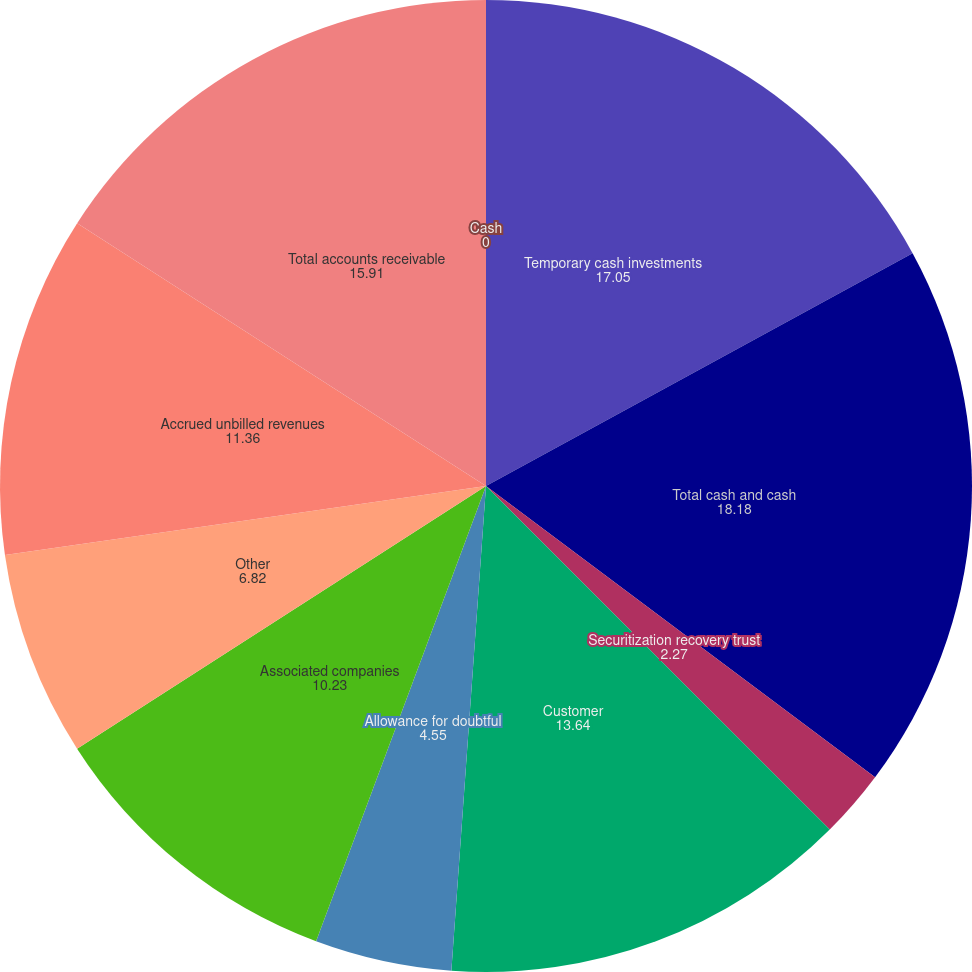<chart> <loc_0><loc_0><loc_500><loc_500><pie_chart><fcel>Cash<fcel>Temporary cash investments<fcel>Total cash and cash<fcel>Securitization recovery trust<fcel>Customer<fcel>Allowance for doubtful<fcel>Associated companies<fcel>Other<fcel>Accrued unbilled revenues<fcel>Total accounts receivable<nl><fcel>0.0%<fcel>17.05%<fcel>18.18%<fcel>2.27%<fcel>13.64%<fcel>4.55%<fcel>10.23%<fcel>6.82%<fcel>11.36%<fcel>15.91%<nl></chart> 